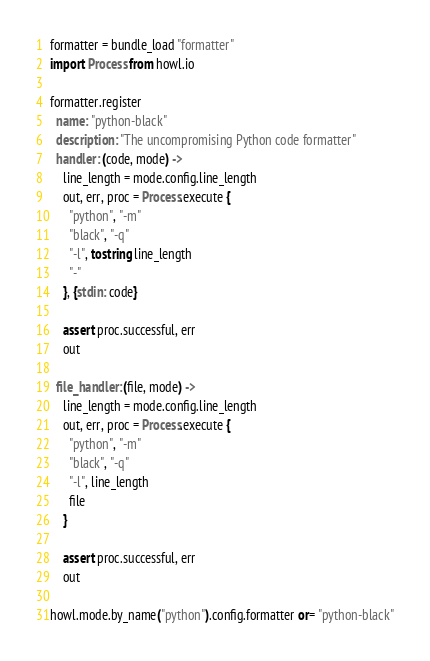Convert code to text. <code><loc_0><loc_0><loc_500><loc_500><_MoonScript_>formatter = bundle_load "formatter"
import Process from howl.io

formatter.register
  name: "python-black"
  description: "The uncompromising Python code formatter"
  handler: (code, mode) ->
    line_length = mode.config.line_length
    out, err, proc = Process.execute {
      "python", "-m"
      "black", "-q"
      "-l", tostring line_length
      "-"
    }, {stdin: code}

    assert proc.successful, err
    out

  file_handler: (file, mode) ->
    line_length = mode.config.line_length
    out, err, proc = Process.execute {
      "python", "-m"
      "black", "-q"
      "-l", line_length
      file
    }

    assert proc.successful, err
    out

howl.mode.by_name("python").config.formatter or= "python-black"
</code> 